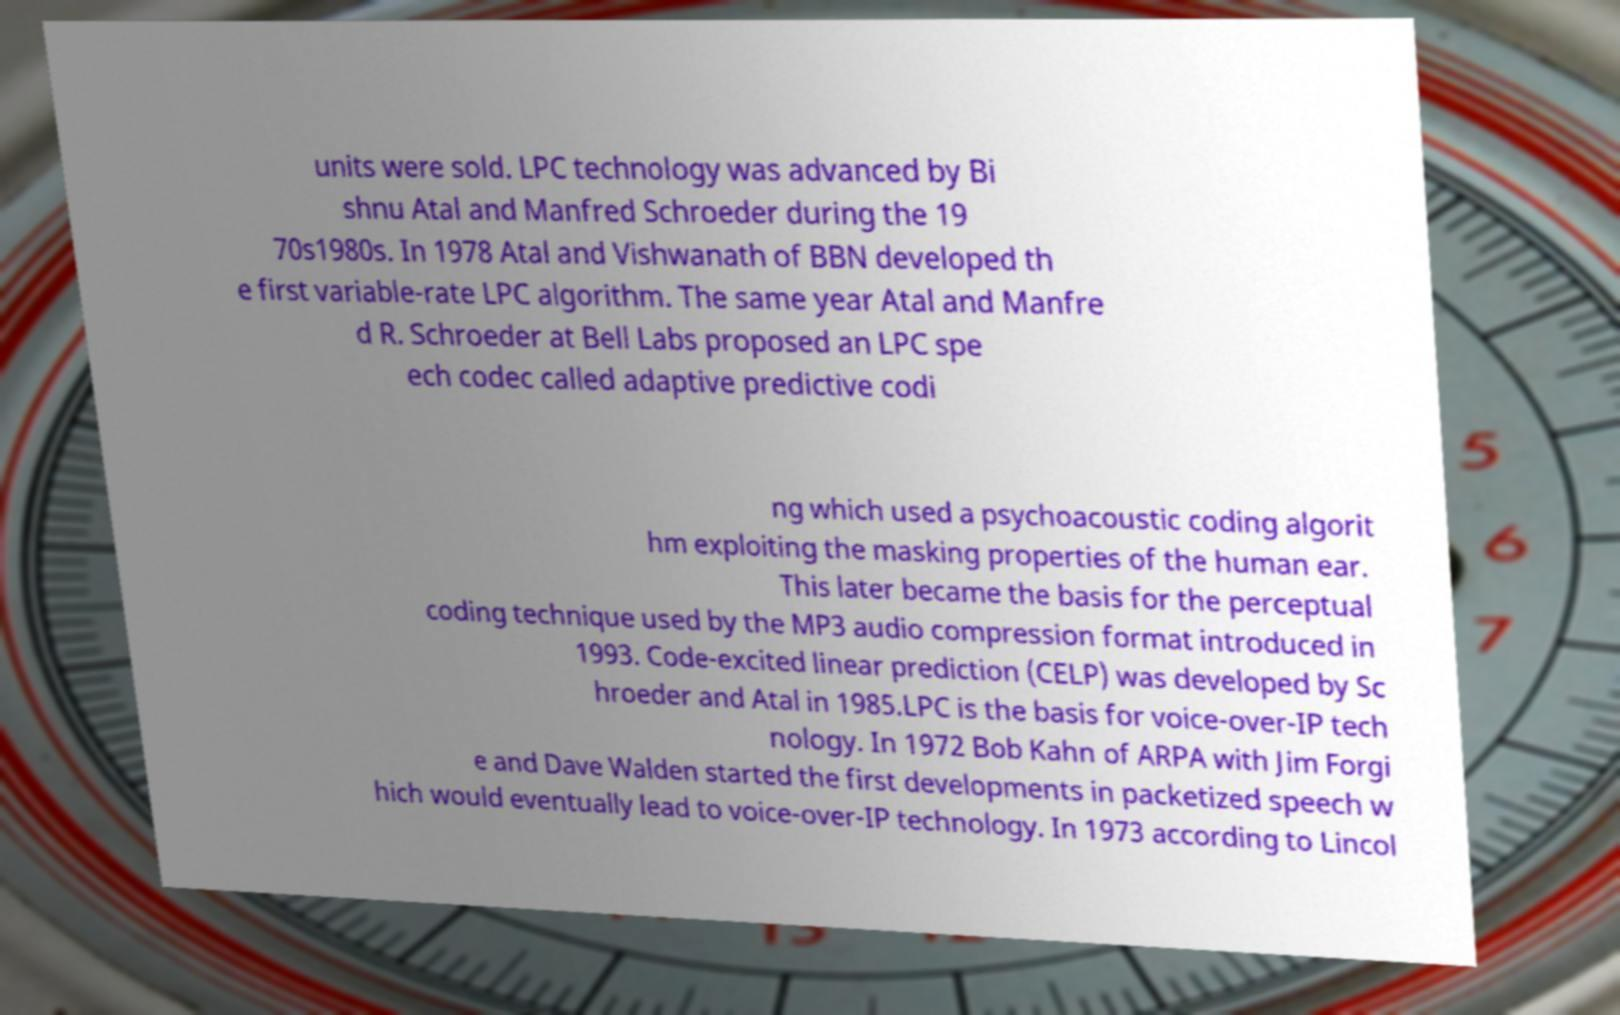Can you read and provide the text displayed in the image?This photo seems to have some interesting text. Can you extract and type it out for me? units were sold. LPC technology was advanced by Bi shnu Atal and Manfred Schroeder during the 19 70s1980s. In 1978 Atal and Vishwanath of BBN developed th e first variable-rate LPC algorithm. The same year Atal and Manfre d R. Schroeder at Bell Labs proposed an LPC spe ech codec called adaptive predictive codi ng which used a psychoacoustic coding algorit hm exploiting the masking properties of the human ear. This later became the basis for the perceptual coding technique used by the MP3 audio compression format introduced in 1993. Code-excited linear prediction (CELP) was developed by Sc hroeder and Atal in 1985.LPC is the basis for voice-over-IP tech nology. In 1972 Bob Kahn of ARPA with Jim Forgi e and Dave Walden started the first developments in packetized speech w hich would eventually lead to voice-over-IP technology. In 1973 according to Lincol 